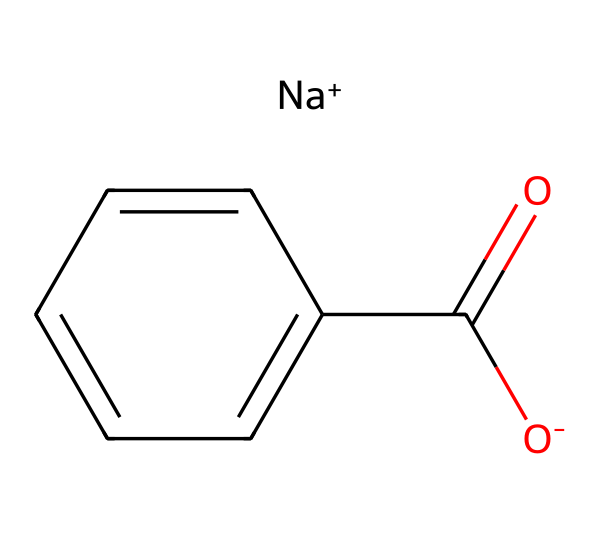What is the chemical name of this compound? The SMILES notation indicates the presence of a sodium ion (Na+) and a benzoate structure (O-C(=O)-c1ccccc1), which together form sodium benzoate.
Answer: sodium benzoate How many carbon atoms are present in the structure? Examining the SMILES, the structure shows six carbons in the benzene ring plus one carbon in the carboxylate group (C(=O)-), totaling seven carbon atoms.
Answer: 7 What functional group is present in sodium benzoate? The presence of the carboxylate (C(=O)-O-) portion of the structure identifies it as a carboxylate functional group, which is characteristic of sodium benzoate.
Answer: carboxylate What is the total number of hydrogen atoms attached to sodium benzoate? The benzene ring in the structure has five hydrogen atoms, and the carboxylate (-COO-) contributes one effective hydrogen. Therefore, the compound has a total of five hydrogen atoms.
Answer: 5 Is sodium benzoate an ionic or molecular compound? The presence of the sodium ion (Na+) indicates that sodium benzoate is an ionic compound because it consists of positively charged ions (sodium) and negatively charged ions (benzoate).
Answer: ionic What is the primary use of sodium benzoate in food products? Sodium benzoate is primarily used as a preservative in food products, helping to prevent spoilage and extend shelf life.
Answer: preservative 